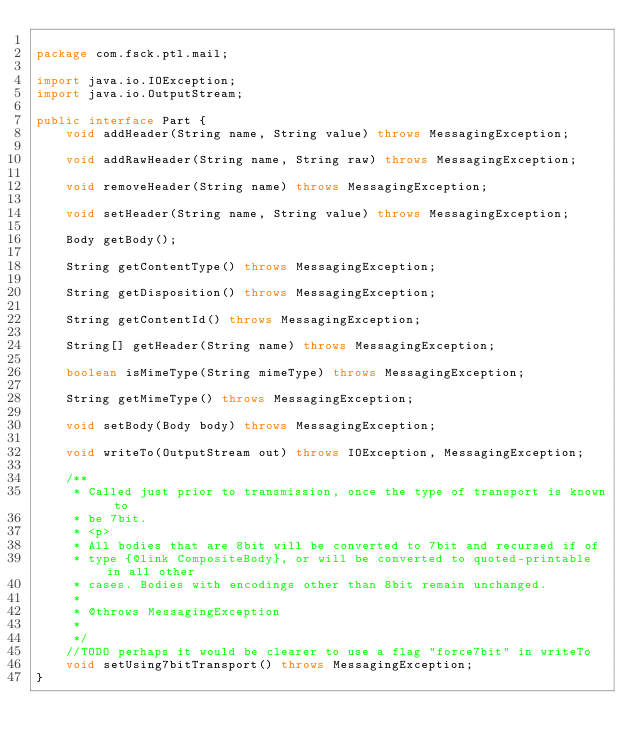<code> <loc_0><loc_0><loc_500><loc_500><_Java_>
package com.fsck.ptl.mail;

import java.io.IOException;
import java.io.OutputStream;

public interface Part {
    void addHeader(String name, String value) throws MessagingException;

    void addRawHeader(String name, String raw) throws MessagingException;

    void removeHeader(String name) throws MessagingException;

    void setHeader(String name, String value) throws MessagingException;

    Body getBody();

    String getContentType() throws MessagingException;

    String getDisposition() throws MessagingException;

    String getContentId() throws MessagingException;

    String[] getHeader(String name) throws MessagingException;

    boolean isMimeType(String mimeType) throws MessagingException;

    String getMimeType() throws MessagingException;

    void setBody(Body body) throws MessagingException;

    void writeTo(OutputStream out) throws IOException, MessagingException;

    /**
     * Called just prior to transmission, once the type of transport is known to
     * be 7bit.
     * <p>
     * All bodies that are 8bit will be converted to 7bit and recursed if of
     * type {@link CompositeBody}, or will be converted to quoted-printable in all other
     * cases. Bodies with encodings other than 8bit remain unchanged.
     *
     * @throws MessagingException
     *
     */
    //TODO perhaps it would be clearer to use a flag "force7bit" in writeTo
    void setUsing7bitTransport() throws MessagingException;
}
</code> 